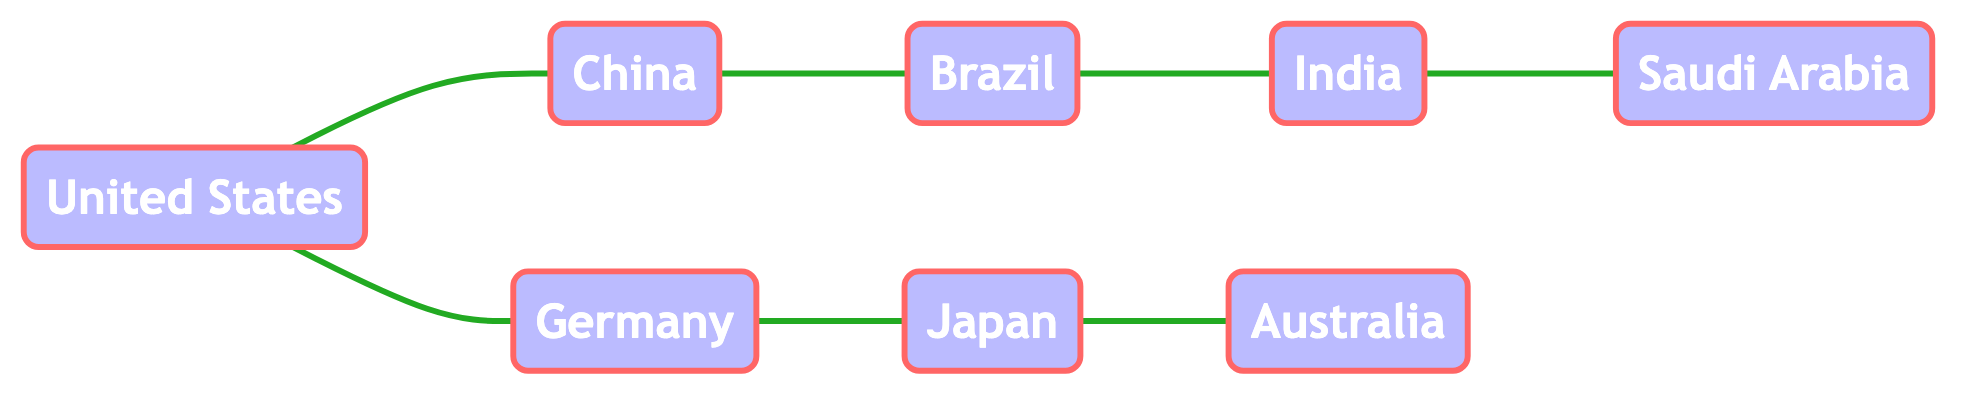What are the major exports of the United States? According to the information in the diagram, the major exports of the United States are automobiles, technology, and machinery.
Answer: automobiles, technology, machinery How many countries are connected to China in the diagram? By examining the diagram, China has direct connections (edges) to two countries: the USA and Brazil.
Answer: 2 What does India export to Saudi Arabia? The diagram indicates that India exports textiles to Saudi Arabia, as explicitly stated in the connection information.
Answer: textiles Who imports machinery from Germany? The connection from Germany points directly to the USA, indicating that the USA imports machinery from Germany.
Answer: USA Which country exports oil to Brazil? Looking at the connections in the diagram, there is no direct reference to Brazil importing oil from another country; however, it's evident that Brazil exports iron ore to India, but it does not indicate oil imports in relation to this question. Thus, the question is problematic.
Answer: N/A What is the flow of electronics between the USA and China? The diagram notes that the USA exports technology to China while importing electronics from China, indicating a mutual trade relationship involving electronics.
Answer: USA exports technology, imports electronics Identify a major import of Japan from Australia. The connection between Japan and Australia shows that Japan imports coal from Australia, as specified in the relationship information.
Answer: coal What is a common import for Saudi Arabia from another country? According to the information, Saudi Arabia imports machinery from India, illustrating that machinery is a significant import for Saudi Arabia.
Answer: machinery 